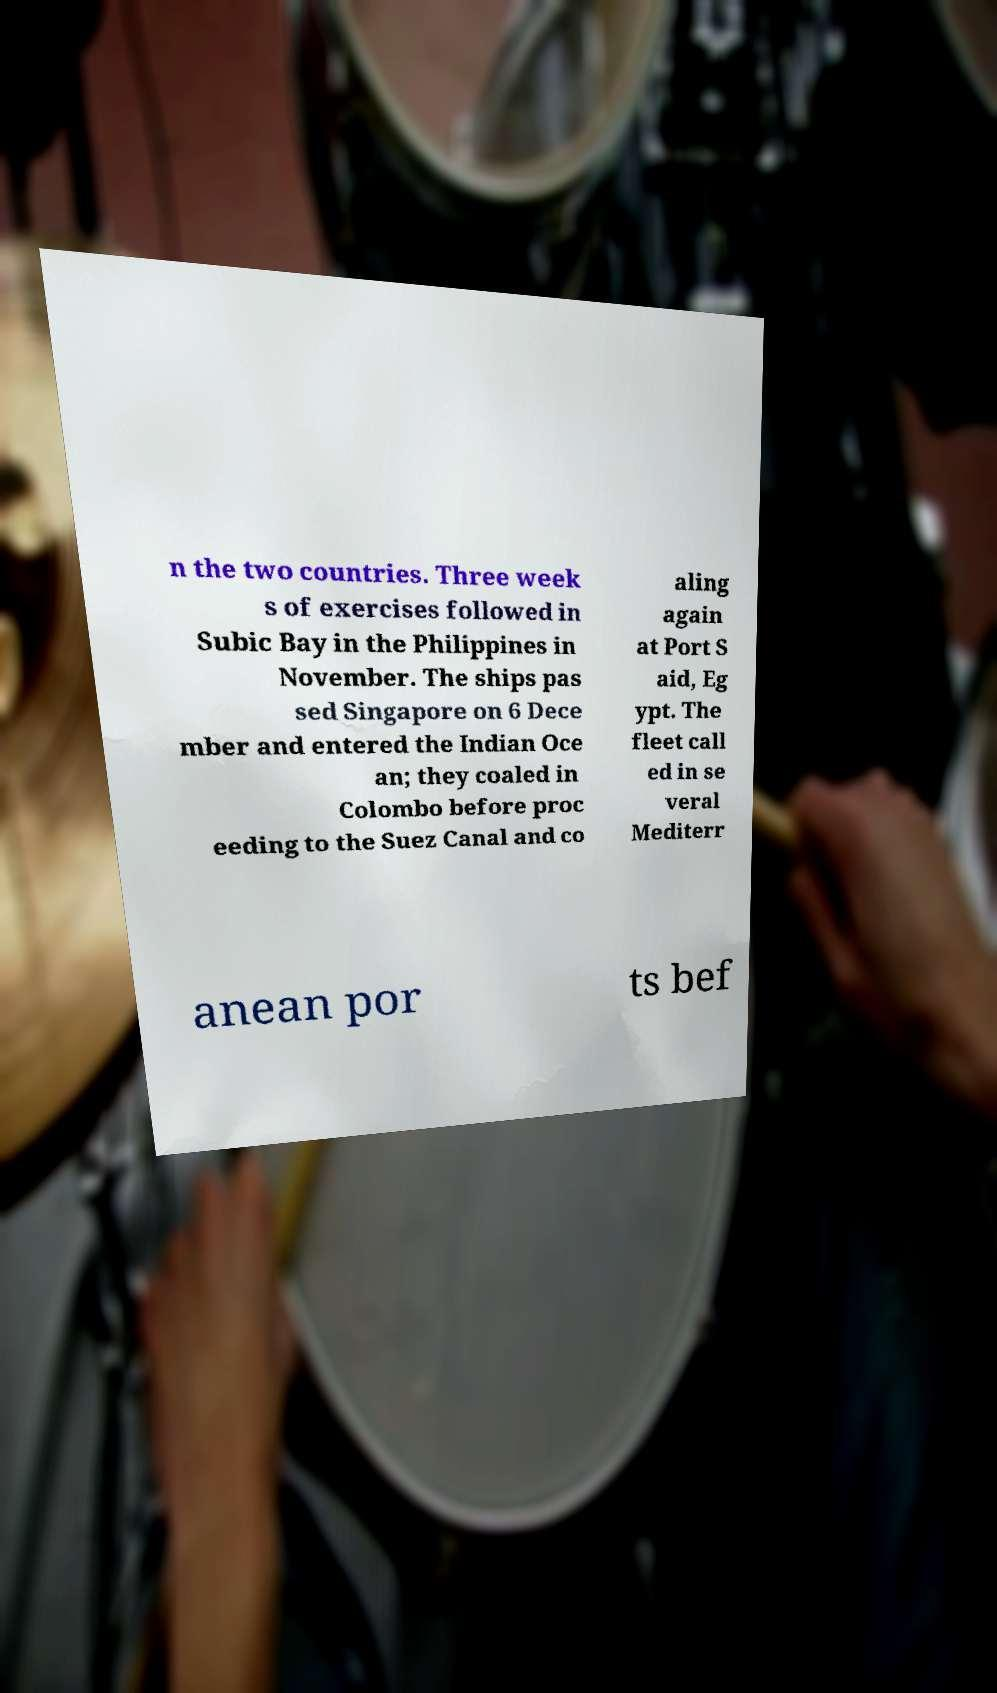I need the written content from this picture converted into text. Can you do that? n the two countries. Three week s of exercises followed in Subic Bay in the Philippines in November. The ships pas sed Singapore on 6 Dece mber and entered the Indian Oce an; they coaled in Colombo before proc eeding to the Suez Canal and co aling again at Port S aid, Eg ypt. The fleet call ed in se veral Mediterr anean por ts bef 